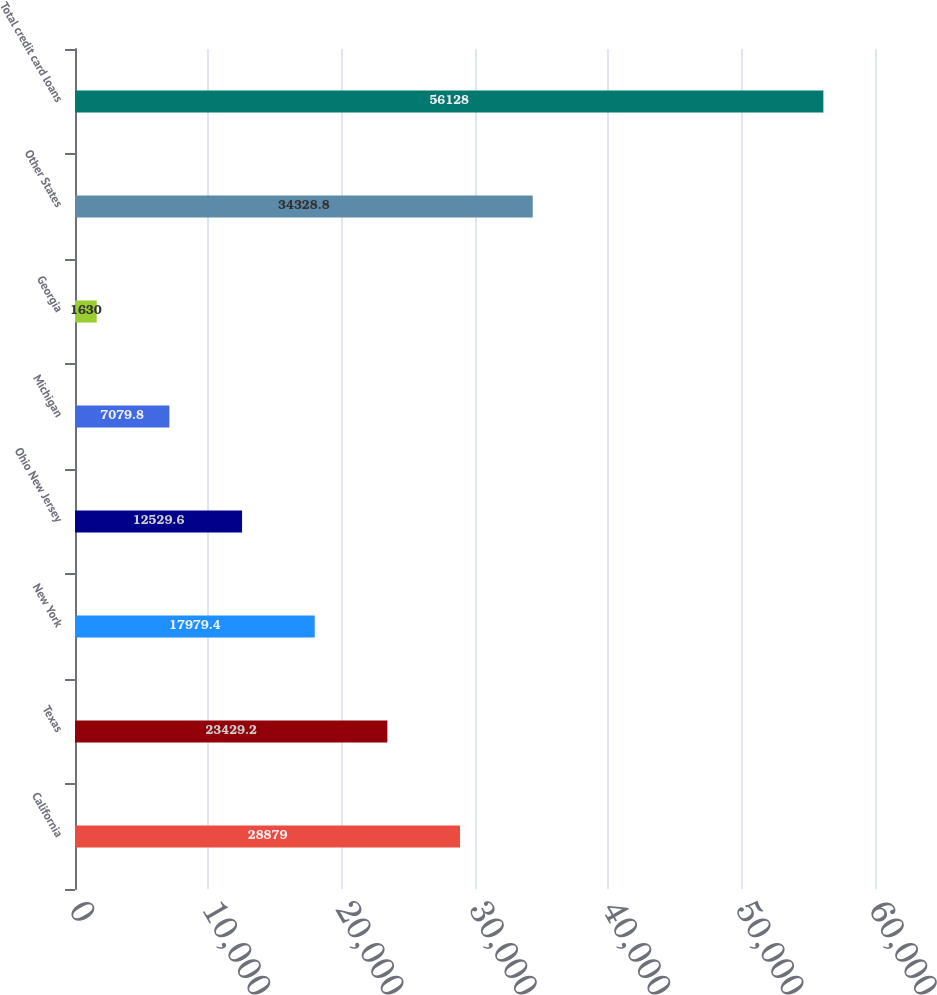<chart> <loc_0><loc_0><loc_500><loc_500><bar_chart><fcel>California<fcel>Texas<fcel>New York<fcel>Ohio New Jersey<fcel>Michigan<fcel>Georgia<fcel>Other States<fcel>Total credit card loans<nl><fcel>28879<fcel>23429.2<fcel>17979.4<fcel>12529.6<fcel>7079.8<fcel>1630<fcel>34328.8<fcel>56128<nl></chart> 